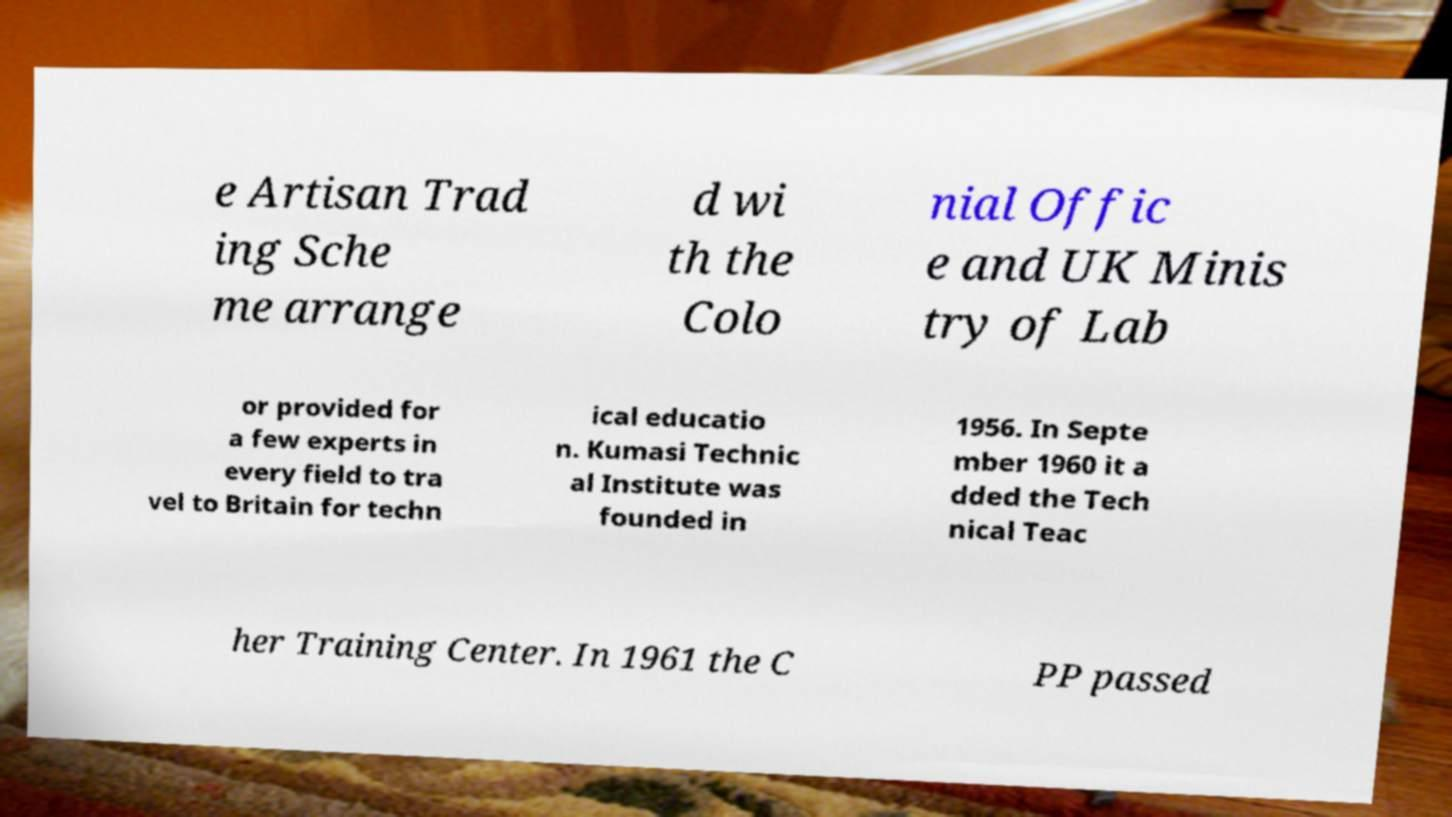For documentation purposes, I need the text within this image transcribed. Could you provide that? e Artisan Trad ing Sche me arrange d wi th the Colo nial Offic e and UK Minis try of Lab or provided for a few experts in every field to tra vel to Britain for techn ical educatio n. Kumasi Technic al Institute was founded in 1956. In Septe mber 1960 it a dded the Tech nical Teac her Training Center. In 1961 the C PP passed 